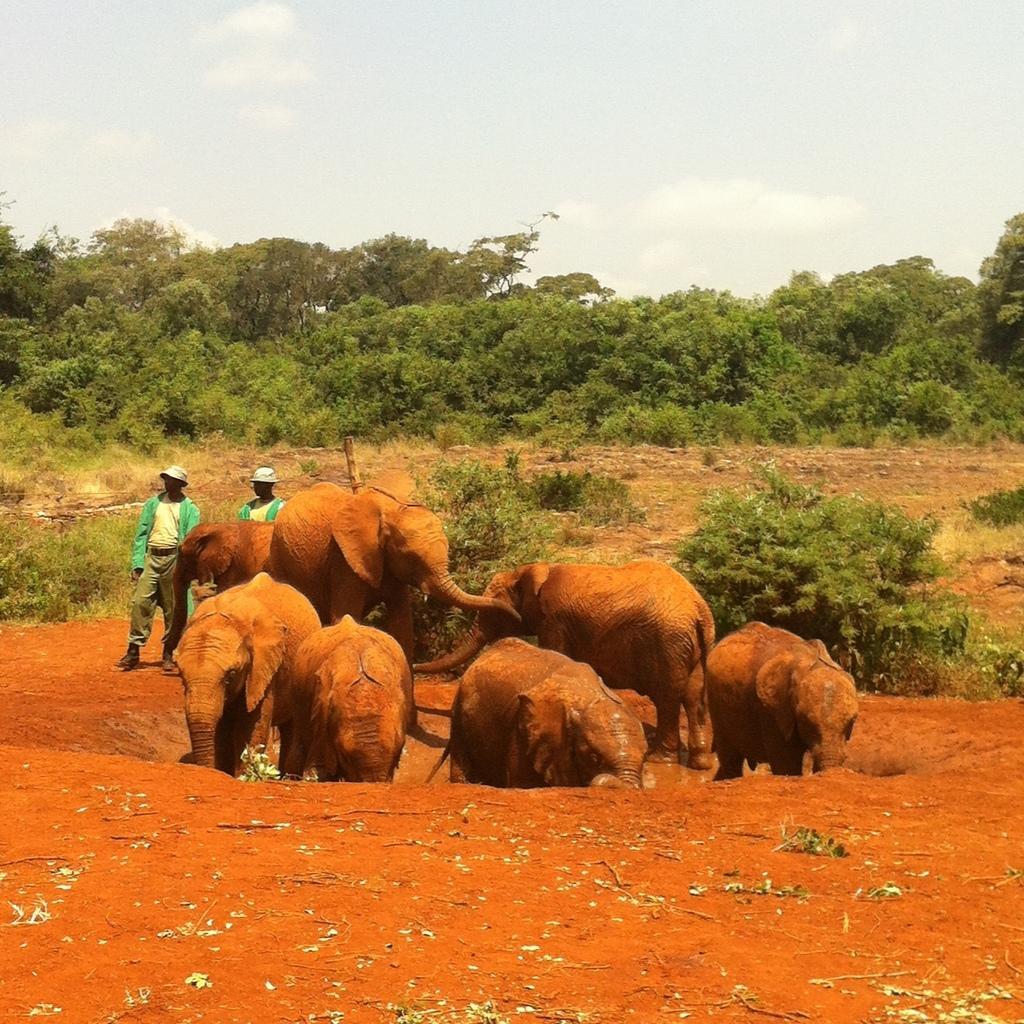In one or two sentences, can you explain what this image depicts? In this picture we can observe a herd of elephants. There are two persons standing on the left side. In the background there are some trees. We can observe a sky with some clouds. 